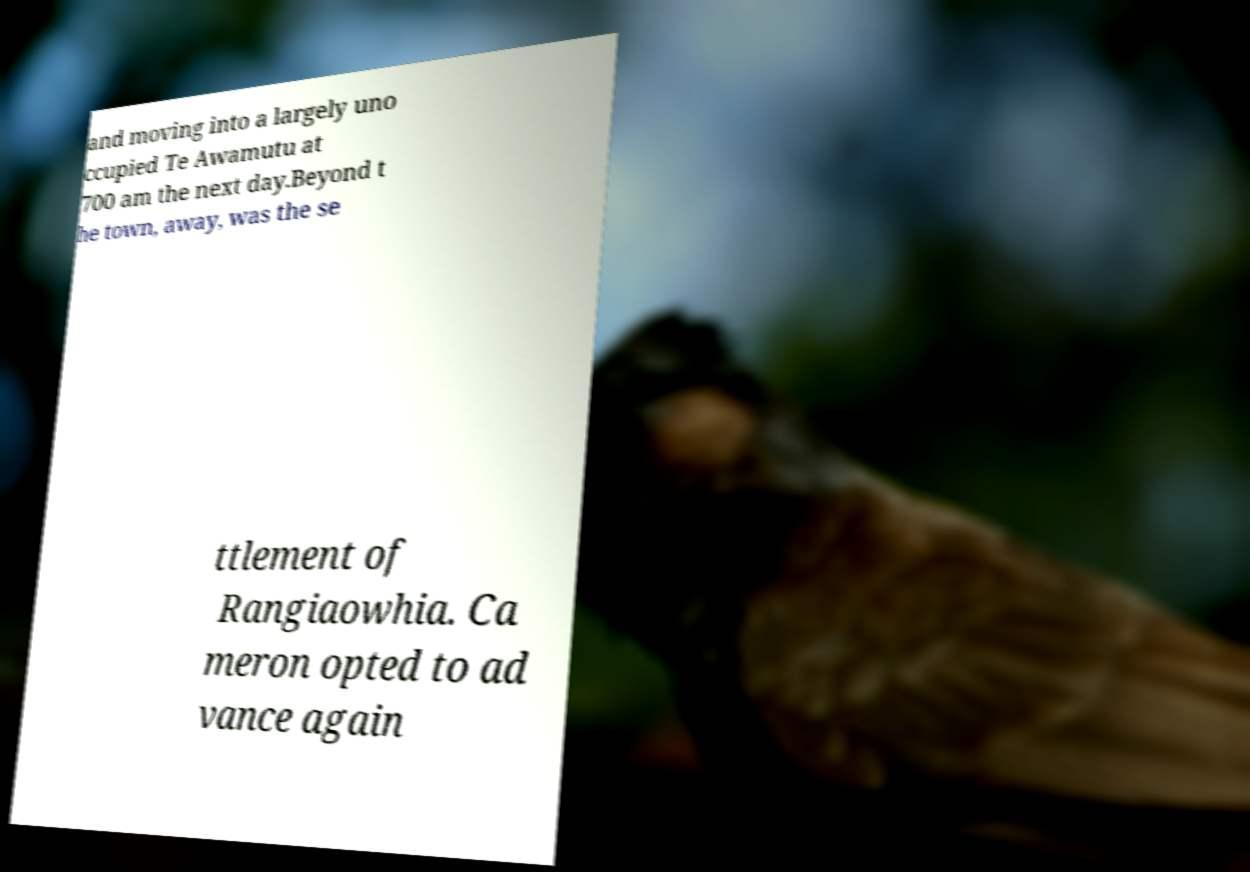There's text embedded in this image that I need extracted. Can you transcribe it verbatim? and moving into a largely uno ccupied Te Awamutu at 700 am the next day.Beyond t he town, away, was the se ttlement of Rangiaowhia. Ca meron opted to ad vance again 